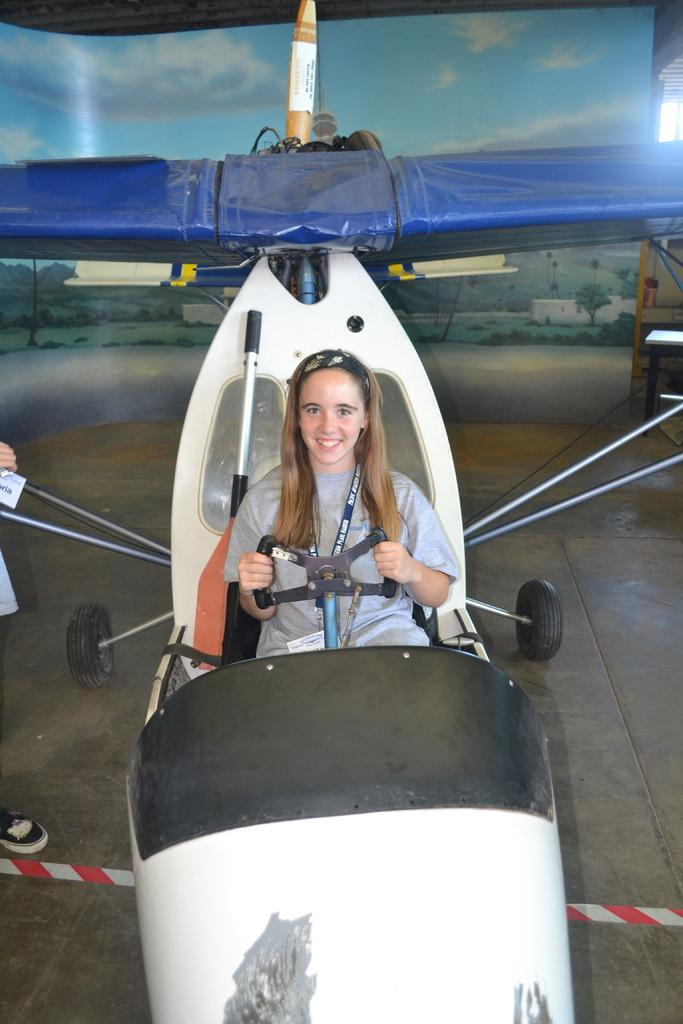What is the lady in the image doing? The lady is sitting in the aircraft. What can be seen in the background of the image? The background of the image includes sky and trees. Can you describe the lighting in the image? There is a light on the right side of the image. What is present on the left side of the image? There is a person on the left side of the image. What is the price of the apparel worn by the lady in the image? There is no information about the price or apparel worn by the lady in the image. Can you see the moon in the image? The moon is not visible in the image; only the sky and trees are present in the background. 